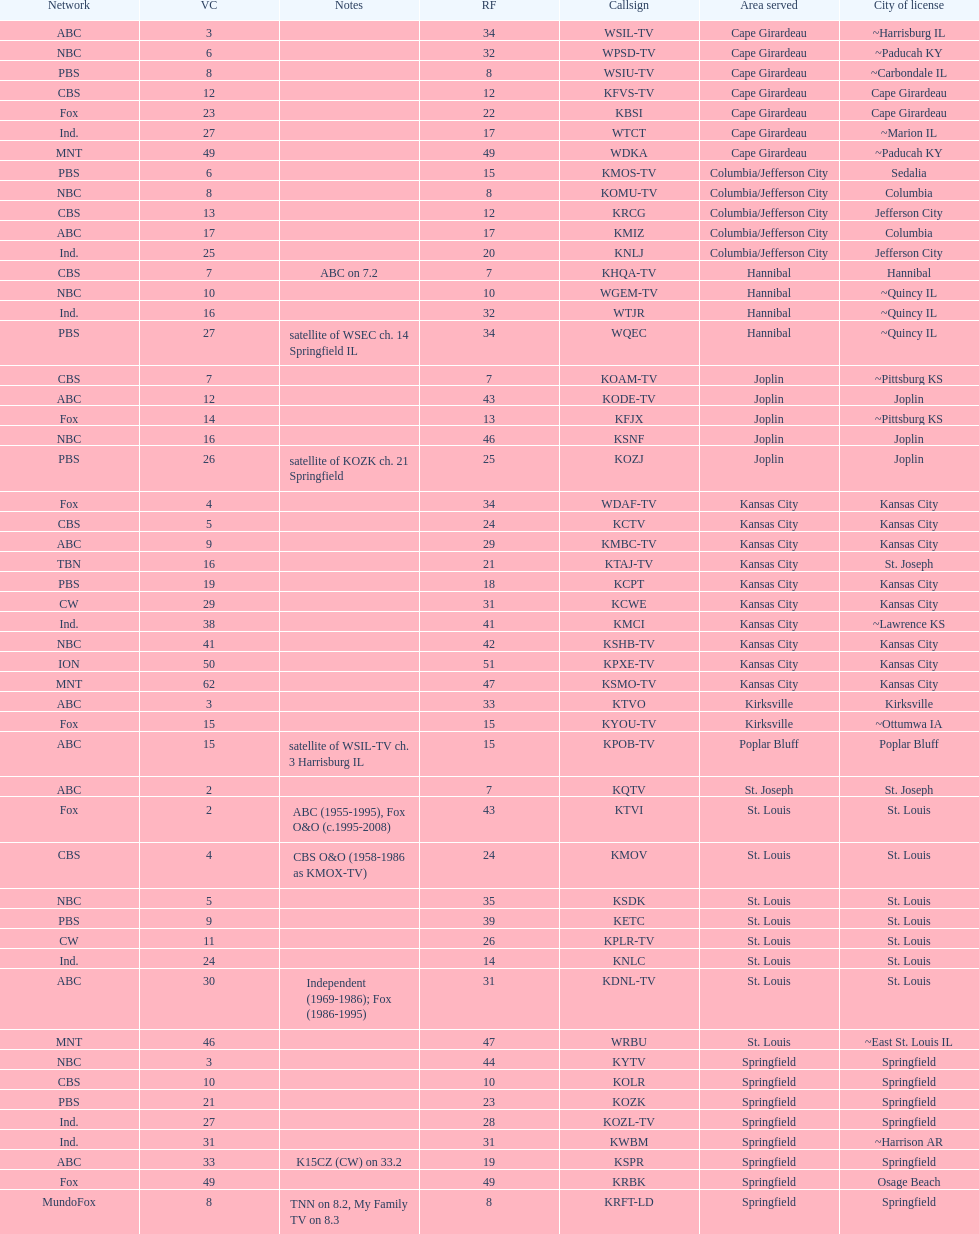What is the total number of stations under the cbs network? 7. 